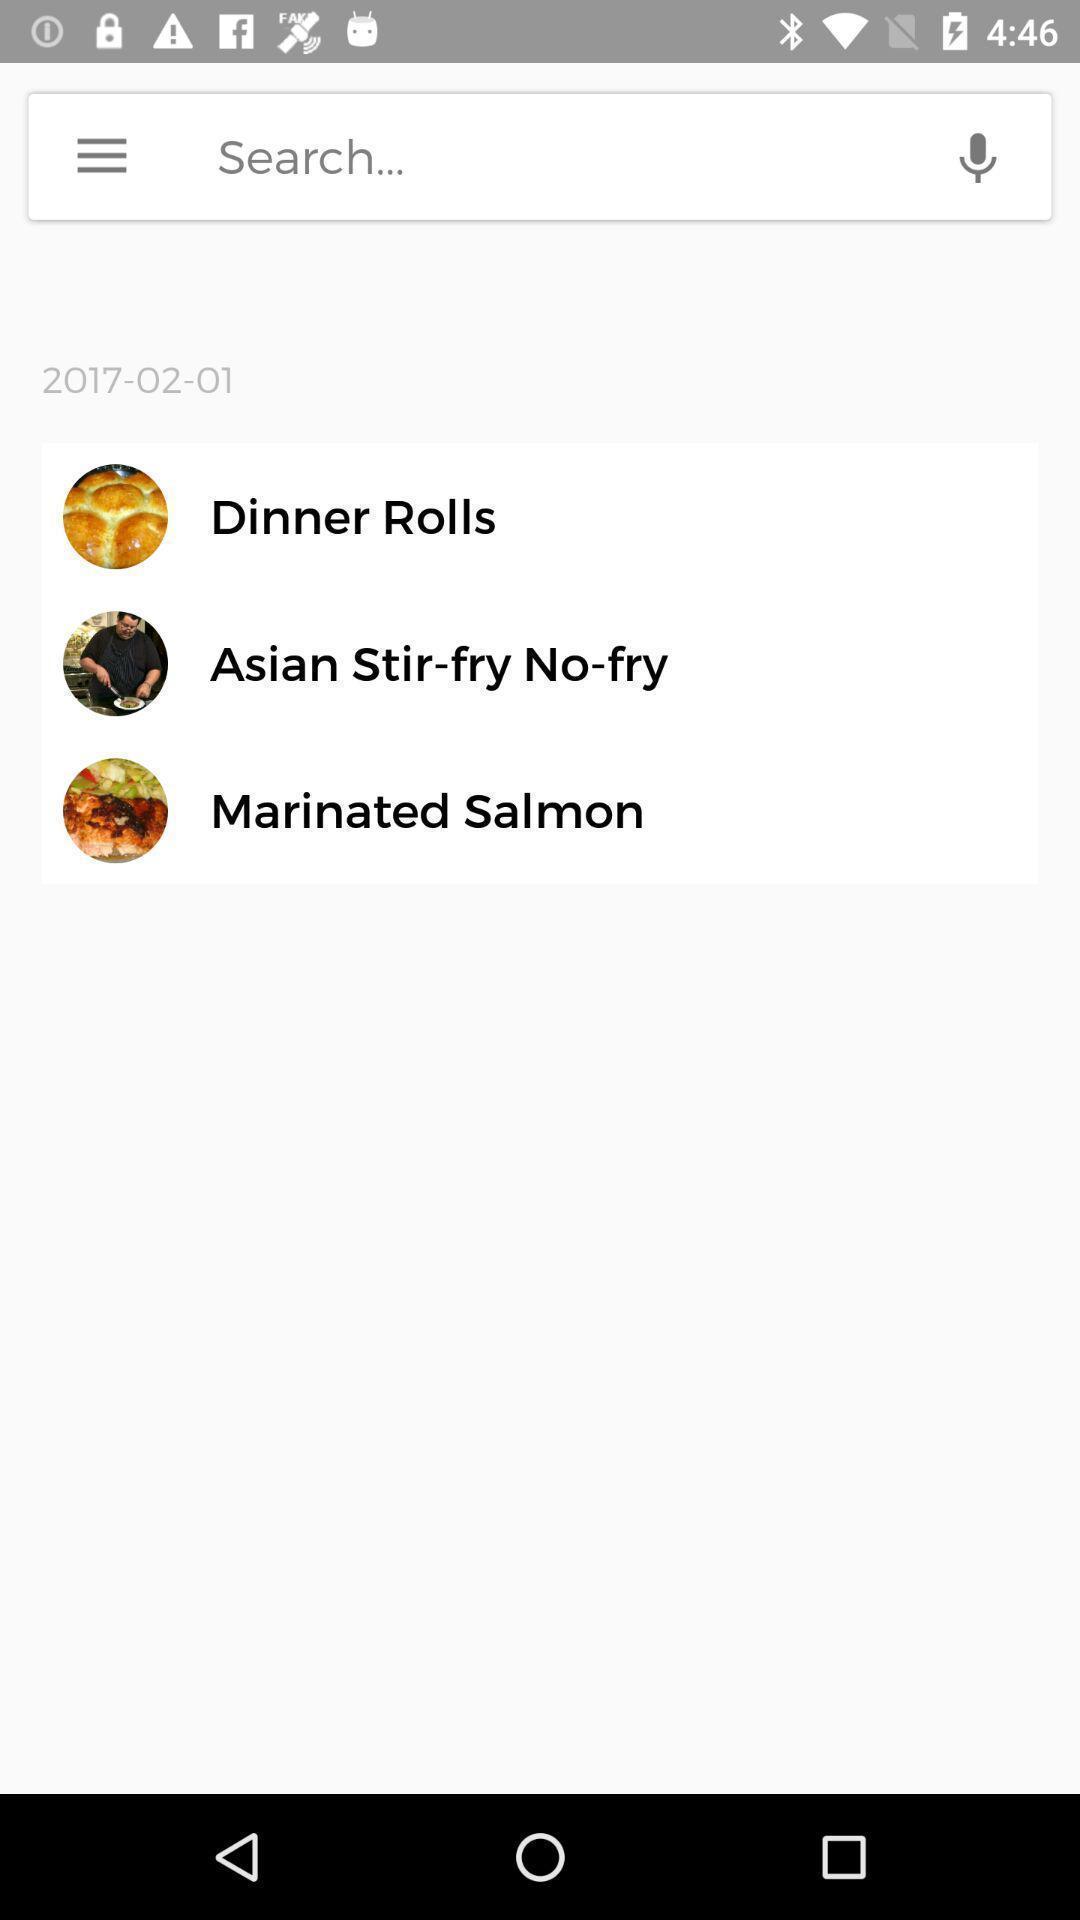Please provide a description for this image. Search option page for various food items in food app. 